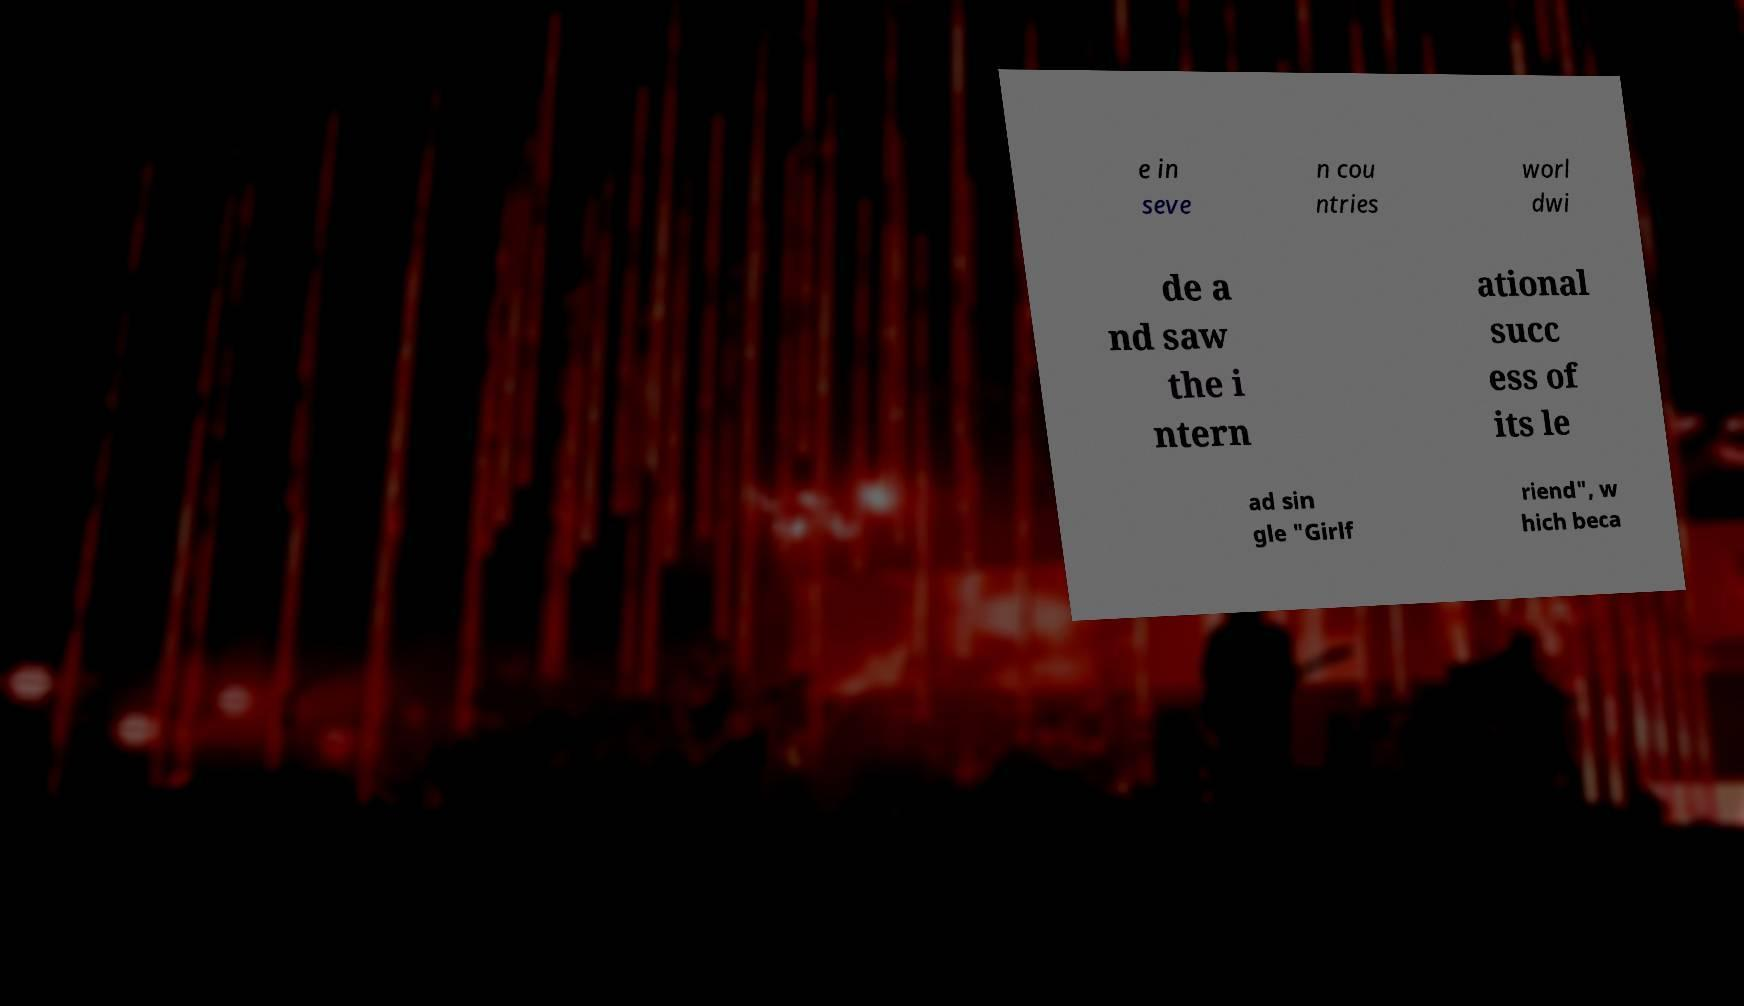Can you accurately transcribe the text from the provided image for me? e in seve n cou ntries worl dwi de a nd saw the i ntern ational succ ess of its le ad sin gle "Girlf riend", w hich beca 